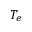Convert formula to latex. <formula><loc_0><loc_0><loc_500><loc_500>T _ { e }</formula> 